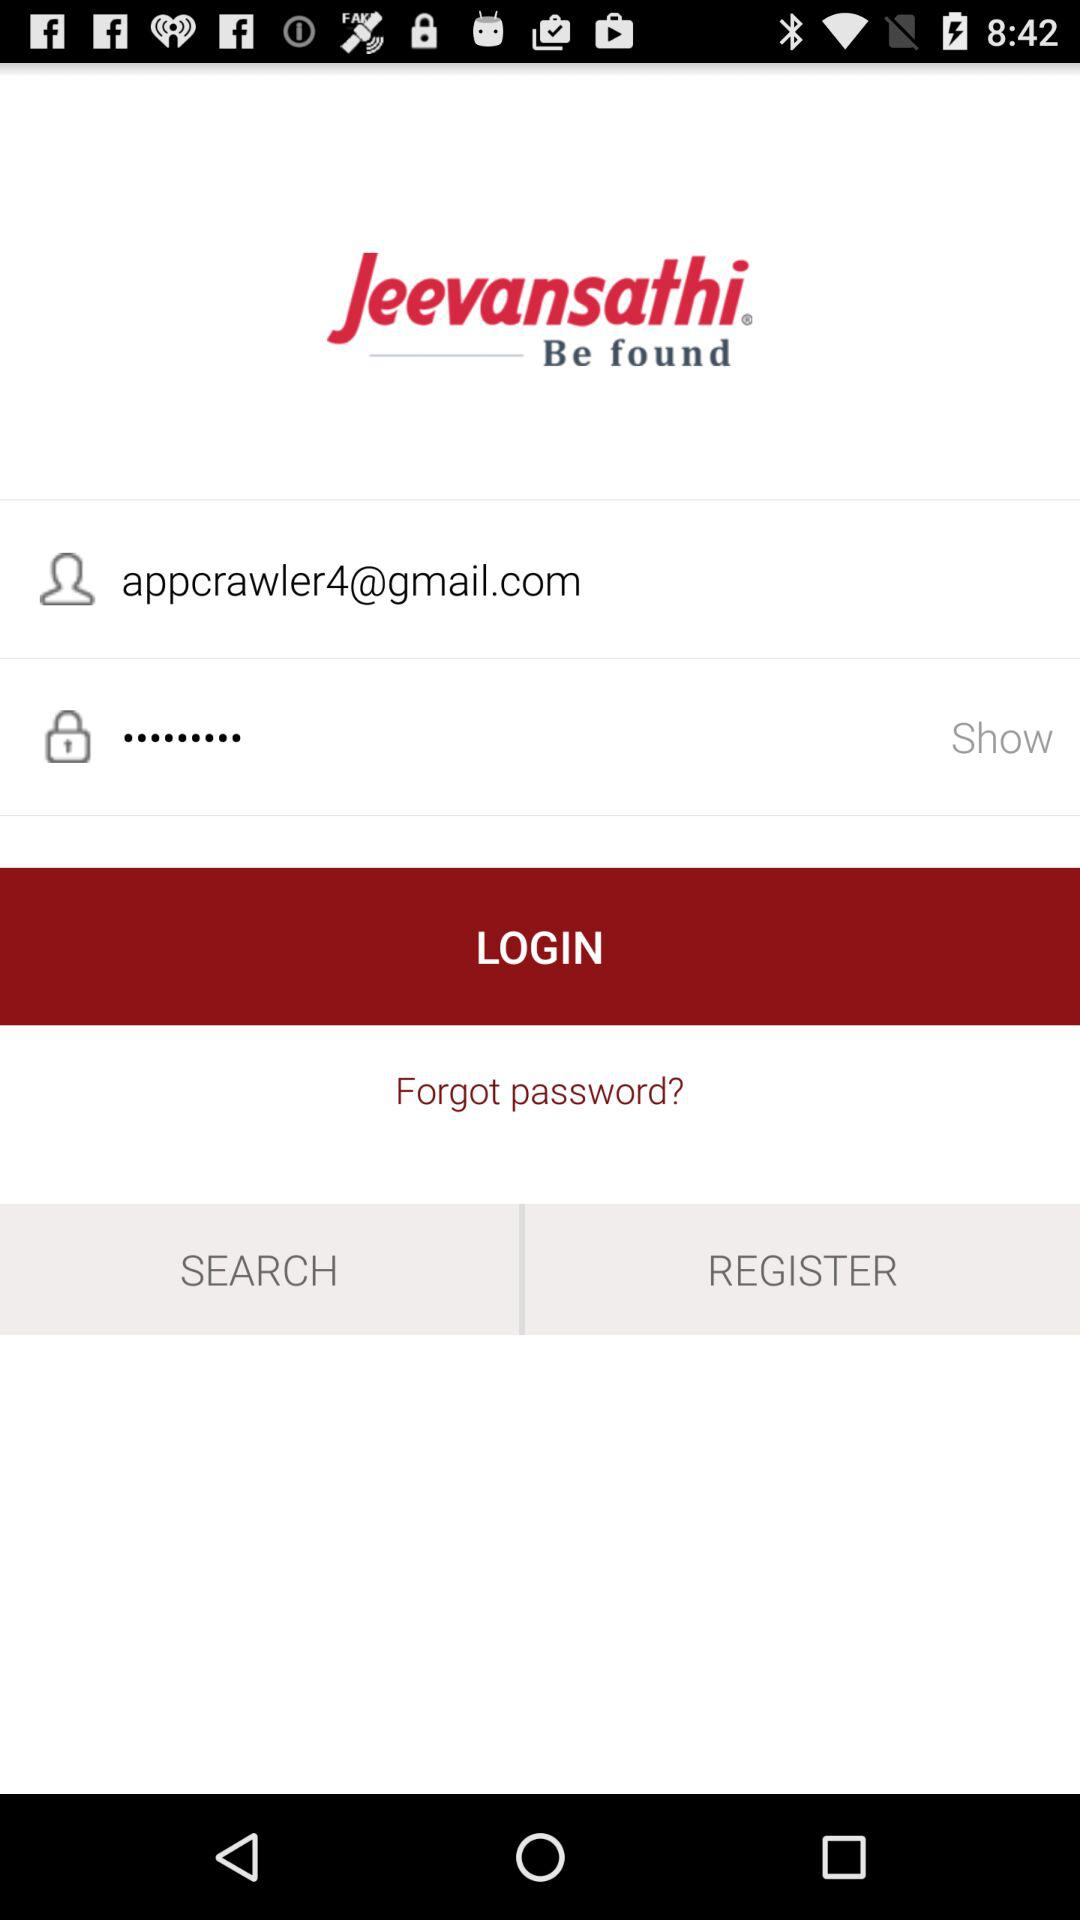What is the email address? The email address is appcrawler4@gmail.com. 